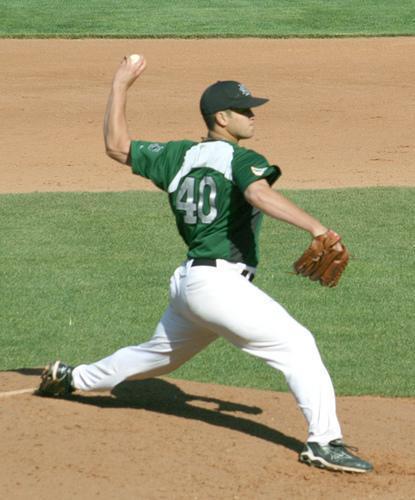How many different colors are on the man's uniform?
Give a very brief answer. 2. 